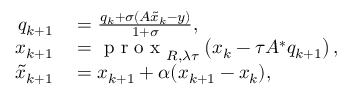<formula> <loc_0><loc_0><loc_500><loc_500>\begin{array} { r l } { q _ { k + 1 } } & = \frac { q _ { k } + \sigma ( A \widetilde { x } _ { k } - y ) } { 1 + \sigma } , } \\ { x _ { k + 1 } } & = p r o x _ { R , \lambda \tau } \left ( x _ { k } - \tau A ^ { * } q _ { k + 1 } \right ) , } \\ { \widetilde { x } _ { k + 1 } } & = x _ { k + 1 } + \alpha ( x _ { k + 1 } - x _ { k } ) , } \end{array}</formula> 